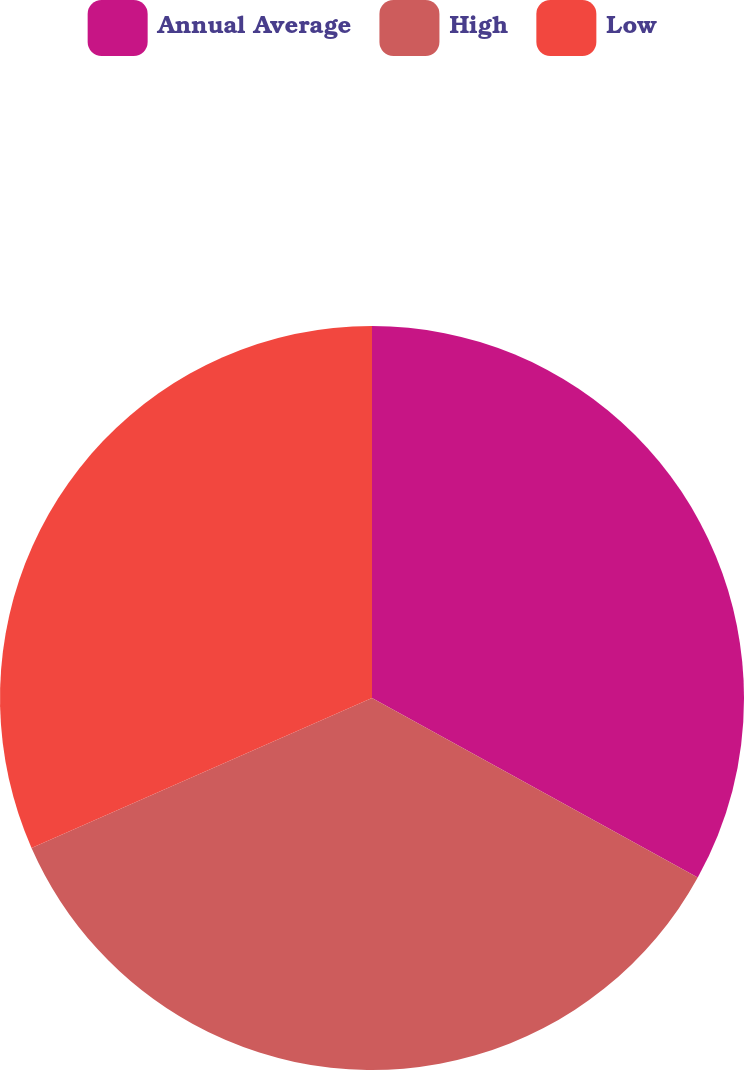Convert chart. <chart><loc_0><loc_0><loc_500><loc_500><pie_chart><fcel>Annual Average<fcel>High<fcel>Low<nl><fcel>33.02%<fcel>35.38%<fcel>31.6%<nl></chart> 